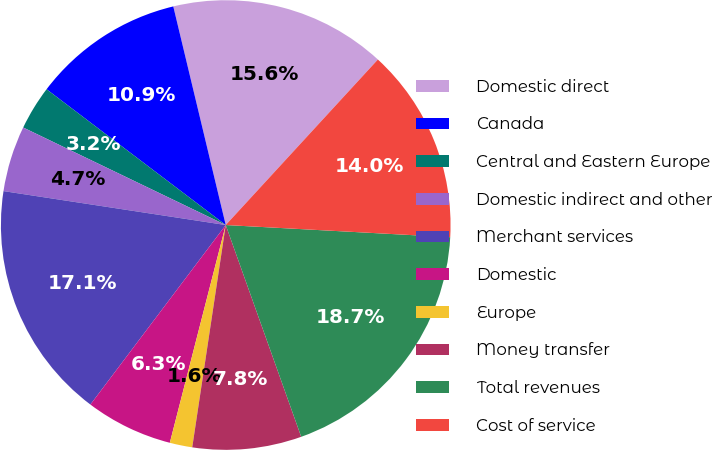<chart> <loc_0><loc_0><loc_500><loc_500><pie_chart><fcel>Domestic direct<fcel>Canada<fcel>Central and Eastern Europe<fcel>Domestic indirect and other<fcel>Merchant services<fcel>Domestic<fcel>Europe<fcel>Money transfer<fcel>Total revenues<fcel>Cost of service<nl><fcel>15.58%<fcel>10.93%<fcel>3.18%<fcel>4.73%<fcel>17.13%<fcel>6.28%<fcel>1.62%<fcel>7.83%<fcel>18.69%<fcel>14.03%<nl></chart> 